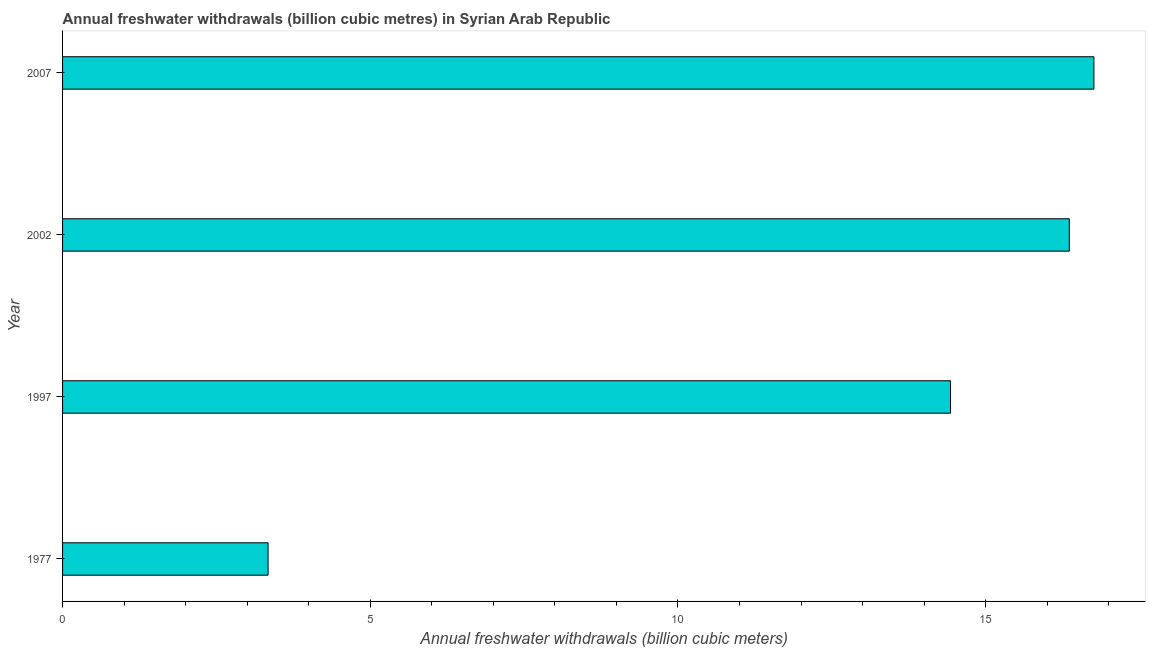Does the graph contain grids?
Your answer should be compact. No. What is the title of the graph?
Make the answer very short. Annual freshwater withdrawals (billion cubic metres) in Syrian Arab Republic. What is the label or title of the X-axis?
Your answer should be very brief. Annual freshwater withdrawals (billion cubic meters). What is the label or title of the Y-axis?
Offer a terse response. Year. What is the annual freshwater withdrawals in 2007?
Provide a short and direct response. 16.76. Across all years, what is the maximum annual freshwater withdrawals?
Give a very brief answer. 16.76. Across all years, what is the minimum annual freshwater withdrawals?
Ensure brevity in your answer.  3.34. In which year was the annual freshwater withdrawals maximum?
Provide a short and direct response. 2007. In which year was the annual freshwater withdrawals minimum?
Offer a very short reply. 1977. What is the sum of the annual freshwater withdrawals?
Your answer should be very brief. 50.89. What is the difference between the annual freshwater withdrawals in 2002 and 2007?
Your answer should be very brief. -0.4. What is the average annual freshwater withdrawals per year?
Provide a short and direct response. 12.72. What is the median annual freshwater withdrawals?
Your answer should be compact. 15.39. In how many years, is the annual freshwater withdrawals greater than 1 billion cubic meters?
Provide a succinct answer. 4. Do a majority of the years between 1977 and 1997 (inclusive) have annual freshwater withdrawals greater than 11 billion cubic meters?
Provide a succinct answer. No. What is the ratio of the annual freshwater withdrawals in 1997 to that in 2007?
Keep it short and to the point. 0.86. Is the annual freshwater withdrawals in 1977 less than that in 2002?
Provide a short and direct response. Yes. What is the difference between the highest and the lowest annual freshwater withdrawals?
Your answer should be compact. 13.42. How many years are there in the graph?
Make the answer very short. 4. What is the difference between two consecutive major ticks on the X-axis?
Provide a short and direct response. 5. Are the values on the major ticks of X-axis written in scientific E-notation?
Make the answer very short. No. What is the Annual freshwater withdrawals (billion cubic meters) of 1977?
Offer a terse response. 3.34. What is the Annual freshwater withdrawals (billion cubic meters) in 1997?
Offer a terse response. 14.43. What is the Annual freshwater withdrawals (billion cubic meters) in 2002?
Give a very brief answer. 16.36. What is the Annual freshwater withdrawals (billion cubic meters) of 2007?
Provide a short and direct response. 16.76. What is the difference between the Annual freshwater withdrawals (billion cubic meters) in 1977 and 1997?
Your answer should be compact. -11.09. What is the difference between the Annual freshwater withdrawals (billion cubic meters) in 1977 and 2002?
Provide a succinct answer. -13.02. What is the difference between the Annual freshwater withdrawals (billion cubic meters) in 1977 and 2007?
Keep it short and to the point. -13.42. What is the difference between the Annual freshwater withdrawals (billion cubic meters) in 1997 and 2002?
Your answer should be very brief. -1.93. What is the difference between the Annual freshwater withdrawals (billion cubic meters) in 1997 and 2007?
Keep it short and to the point. -2.33. What is the difference between the Annual freshwater withdrawals (billion cubic meters) in 2002 and 2007?
Your answer should be compact. -0.4. What is the ratio of the Annual freshwater withdrawals (billion cubic meters) in 1977 to that in 1997?
Offer a terse response. 0.23. What is the ratio of the Annual freshwater withdrawals (billion cubic meters) in 1977 to that in 2002?
Give a very brief answer. 0.2. What is the ratio of the Annual freshwater withdrawals (billion cubic meters) in 1977 to that in 2007?
Give a very brief answer. 0.2. What is the ratio of the Annual freshwater withdrawals (billion cubic meters) in 1997 to that in 2002?
Give a very brief answer. 0.88. What is the ratio of the Annual freshwater withdrawals (billion cubic meters) in 1997 to that in 2007?
Provide a short and direct response. 0.86. What is the ratio of the Annual freshwater withdrawals (billion cubic meters) in 2002 to that in 2007?
Your response must be concise. 0.98. 